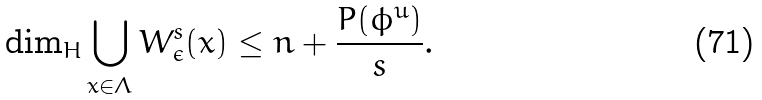<formula> <loc_0><loc_0><loc_500><loc_500>\dim _ { H } \bigcup _ { x \in \Lambda } W ^ { s } _ { \epsilon } ( x ) \leq n + \frac { P ( \phi ^ { u } ) } { s } .</formula> 